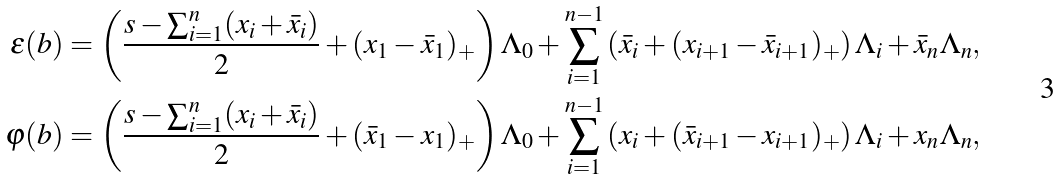<formula> <loc_0><loc_0><loc_500><loc_500>\varepsilon ( b ) & = \left ( \frac { s - \sum _ { i = 1 } ^ { n } ( x _ { i } + \bar { x } _ { i } ) } { 2 } + ( x _ { 1 } - \bar { x } _ { 1 } ) _ { + } \right ) \Lambda _ { 0 } + \sum _ { i = 1 } ^ { n - 1 } \left ( \bar { x } _ { i } + ( x _ { i + 1 } - \bar { x } _ { i + 1 } ) _ { + } \right ) \Lambda _ { i } + \bar { x } _ { n } \Lambda _ { n } , \\ \varphi ( b ) & = \left ( \frac { s - \sum _ { i = 1 } ^ { n } ( x _ { i } + \bar { x } _ { i } ) } { 2 } + ( \bar { x } _ { 1 } - x _ { 1 } ) _ { + } \right ) \Lambda _ { 0 } + \sum _ { i = 1 } ^ { n - 1 } \left ( x _ { i } + ( \bar { x } _ { i + 1 } - x _ { i + 1 } ) _ { + } \right ) \Lambda _ { i } + x _ { n } \Lambda _ { n } , \\</formula> 